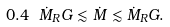<formula> <loc_0><loc_0><loc_500><loc_500>0 . 4 \ \dot { M } _ { R } G \lesssim \dot { M } \lesssim \dot { M } _ { R } G .</formula> 